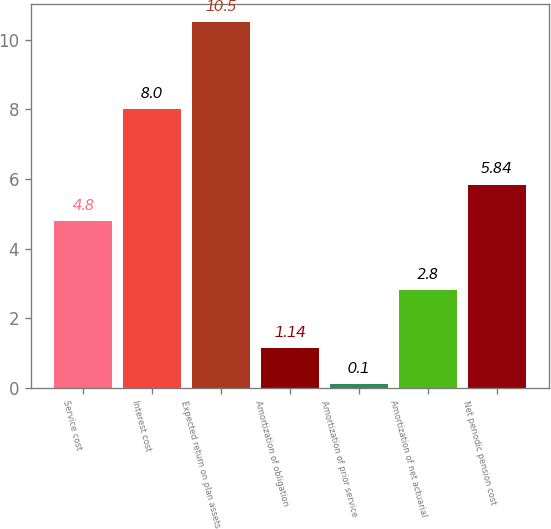Convert chart to OTSL. <chart><loc_0><loc_0><loc_500><loc_500><bar_chart><fcel>Service cost<fcel>Interest cost<fcel>Expected return on plan assets<fcel>Amortization of obligation<fcel>Amortization of prior service<fcel>Amortization of net actuarial<fcel>Net periodic pension cost<nl><fcel>4.8<fcel>8<fcel>10.5<fcel>1.14<fcel>0.1<fcel>2.8<fcel>5.84<nl></chart> 